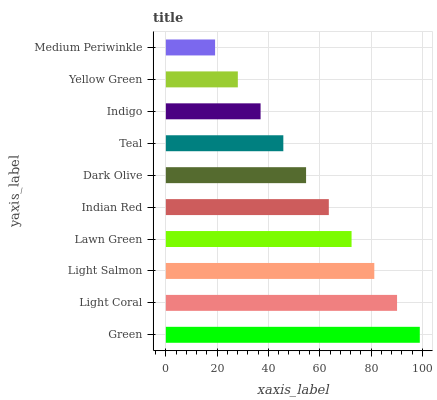Is Medium Periwinkle the minimum?
Answer yes or no. Yes. Is Green the maximum?
Answer yes or no. Yes. Is Light Coral the minimum?
Answer yes or no. No. Is Light Coral the maximum?
Answer yes or no. No. Is Green greater than Light Coral?
Answer yes or no. Yes. Is Light Coral less than Green?
Answer yes or no. Yes. Is Light Coral greater than Green?
Answer yes or no. No. Is Green less than Light Coral?
Answer yes or no. No. Is Indian Red the high median?
Answer yes or no. Yes. Is Dark Olive the low median?
Answer yes or no. Yes. Is Light Coral the high median?
Answer yes or no. No. Is Teal the low median?
Answer yes or no. No. 